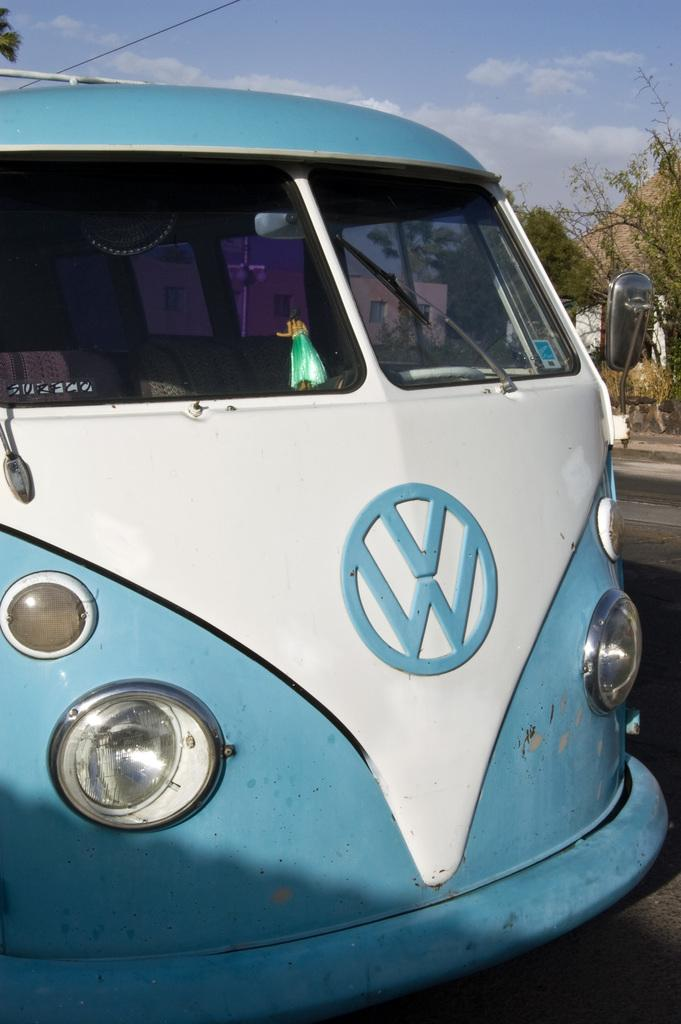Provide a one-sentence caption for the provided image. A blue and white vehicle parked on the road. 